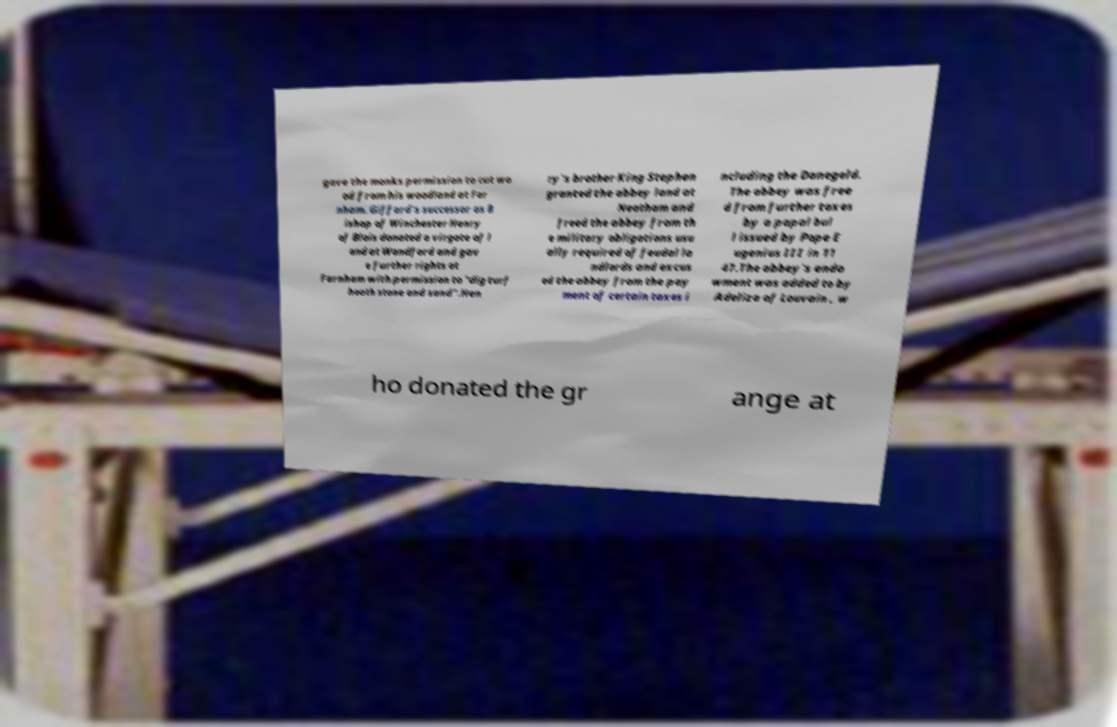I need the written content from this picture converted into text. Can you do that? gave the monks permission to cut wo od from his woodland at Far nham. Giffard's successor as B ishop of Winchester Henry of Blois donated a virgate of l and at Wandford and gav e further rights at Farnham with permission to "dig turf heath stone and sand".Hen ry's brother King Stephen granted the abbey land at Neatham and freed the abbey from th e military obligations usu ally required of feudal la ndlords and excus ed the abbey from the pay ment of certain taxes i ncluding the Danegeld. The abbey was free d from further taxes by a papal bul l issued by Pope E ugenius III in 11 47.The abbey's endo wment was added to by Adeliza of Louvain , w ho donated the gr ange at 